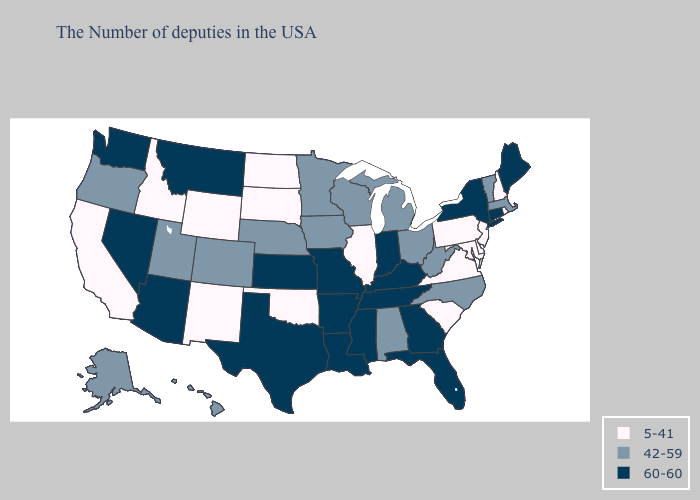Name the states that have a value in the range 60-60?
Concise answer only. Maine, Connecticut, New York, Florida, Georgia, Kentucky, Indiana, Tennessee, Mississippi, Louisiana, Missouri, Arkansas, Kansas, Texas, Montana, Arizona, Nevada, Washington. Does Oregon have the lowest value in the USA?
Be succinct. No. Name the states that have a value in the range 42-59?
Write a very short answer. Massachusetts, Vermont, North Carolina, West Virginia, Ohio, Michigan, Alabama, Wisconsin, Minnesota, Iowa, Nebraska, Colorado, Utah, Oregon, Alaska, Hawaii. What is the value of North Dakota?
Be succinct. 5-41. What is the lowest value in the USA?
Short answer required. 5-41. Which states have the lowest value in the USA?
Concise answer only. Rhode Island, New Hampshire, New Jersey, Delaware, Maryland, Pennsylvania, Virginia, South Carolina, Illinois, Oklahoma, South Dakota, North Dakota, Wyoming, New Mexico, Idaho, California. Among the states that border Florida , which have the highest value?
Concise answer only. Georgia. Does Vermont have the lowest value in the Northeast?
Answer briefly. No. Does the first symbol in the legend represent the smallest category?
Short answer required. Yes. Does Mississippi have the highest value in the USA?
Concise answer only. Yes. Among the states that border Idaho , which have the lowest value?
Keep it brief. Wyoming. Is the legend a continuous bar?
Concise answer only. No. Name the states that have a value in the range 5-41?
Keep it brief. Rhode Island, New Hampshire, New Jersey, Delaware, Maryland, Pennsylvania, Virginia, South Carolina, Illinois, Oklahoma, South Dakota, North Dakota, Wyoming, New Mexico, Idaho, California. Among the states that border Minnesota , which have the highest value?
Concise answer only. Wisconsin, Iowa. Name the states that have a value in the range 42-59?
Be succinct. Massachusetts, Vermont, North Carolina, West Virginia, Ohio, Michigan, Alabama, Wisconsin, Minnesota, Iowa, Nebraska, Colorado, Utah, Oregon, Alaska, Hawaii. 